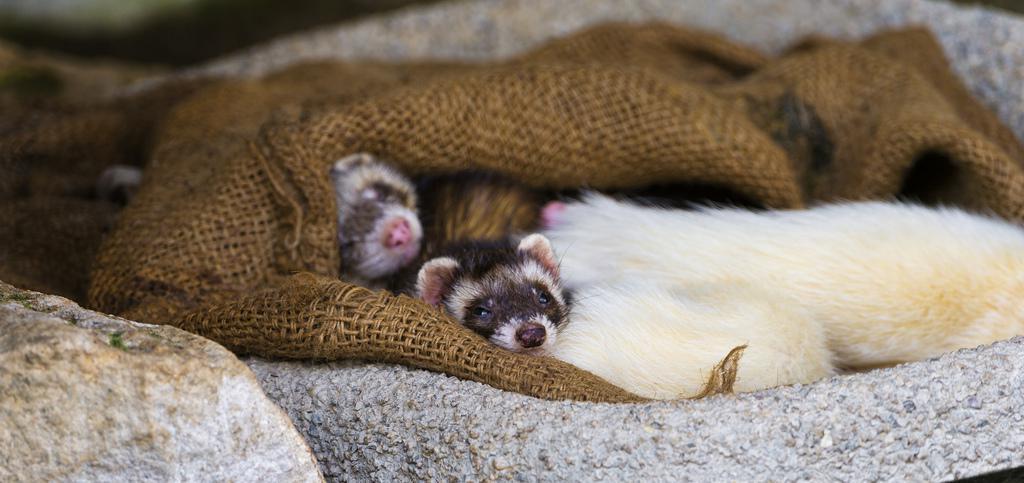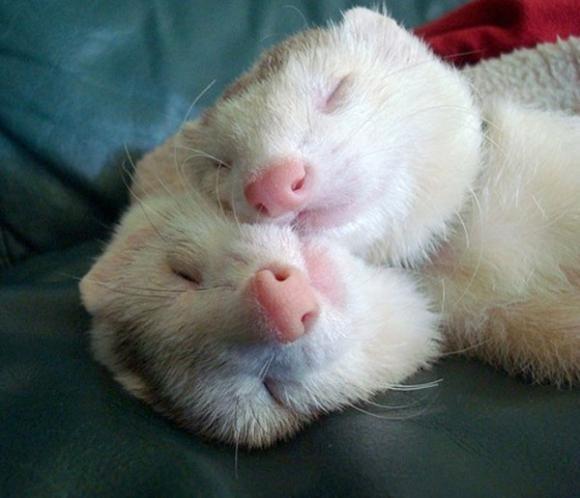The first image is the image on the left, the second image is the image on the right. Analyze the images presented: Is the assertion "there are 3 ferrets being helpd up together by human hands" valid? Answer yes or no. No. The first image is the image on the left, the second image is the image on the right. Assess this claim about the two images: "There is exactly three ferrets in the right image.". Correct or not? Answer yes or no. No. 